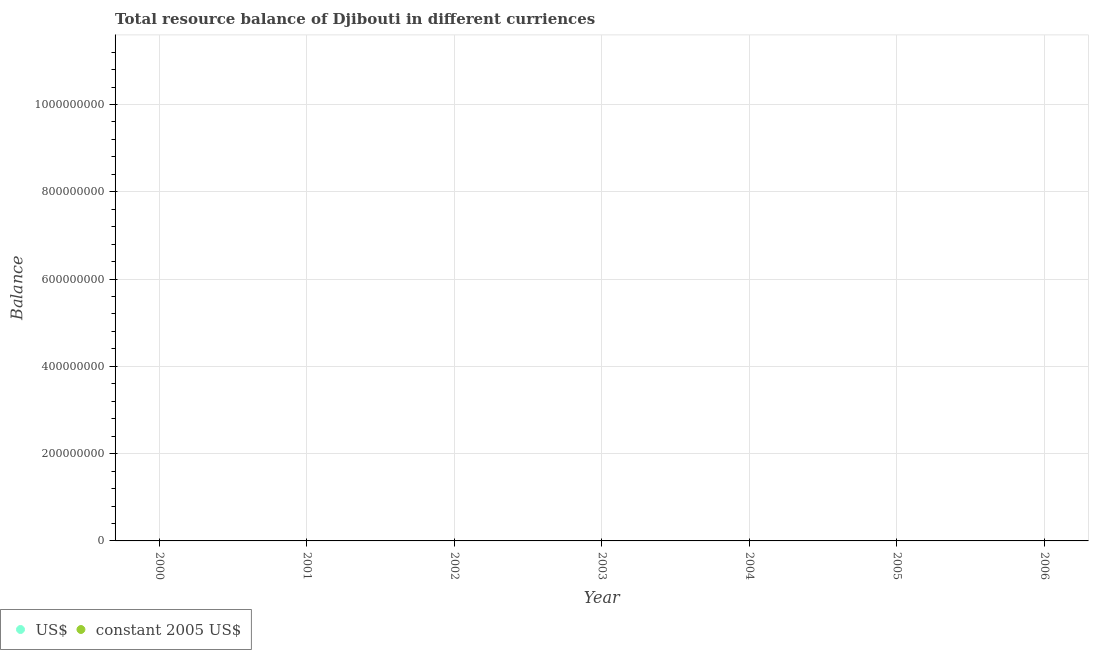How many different coloured dotlines are there?
Ensure brevity in your answer.  0. Is the number of dotlines equal to the number of legend labels?
Give a very brief answer. No. What is the resource balance in us$ in 2005?
Your answer should be compact. 0. Across all years, what is the minimum resource balance in us$?
Keep it short and to the point. 0. In how many years, is the resource balance in us$ greater than the average resource balance in us$ taken over all years?
Make the answer very short. 0. Does the resource balance in us$ monotonically increase over the years?
Provide a succinct answer. No. How many dotlines are there?
Your answer should be compact. 0. Are the values on the major ticks of Y-axis written in scientific E-notation?
Offer a very short reply. No. Does the graph contain any zero values?
Your answer should be compact. Yes. How are the legend labels stacked?
Your answer should be compact. Horizontal. What is the title of the graph?
Your response must be concise. Total resource balance of Djibouti in different curriences. Does "Canada" appear as one of the legend labels in the graph?
Make the answer very short. No. What is the label or title of the Y-axis?
Make the answer very short. Balance. What is the Balance in US$ in 2001?
Your answer should be very brief. 0. What is the Balance of US$ in 2003?
Provide a succinct answer. 0. What is the Balance of constant 2005 US$ in 2003?
Make the answer very short. 0. What is the Balance of US$ in 2004?
Offer a very short reply. 0. What is the Balance of constant 2005 US$ in 2004?
Your answer should be compact. 0. What is the Balance of US$ in 2006?
Provide a short and direct response. 0. 